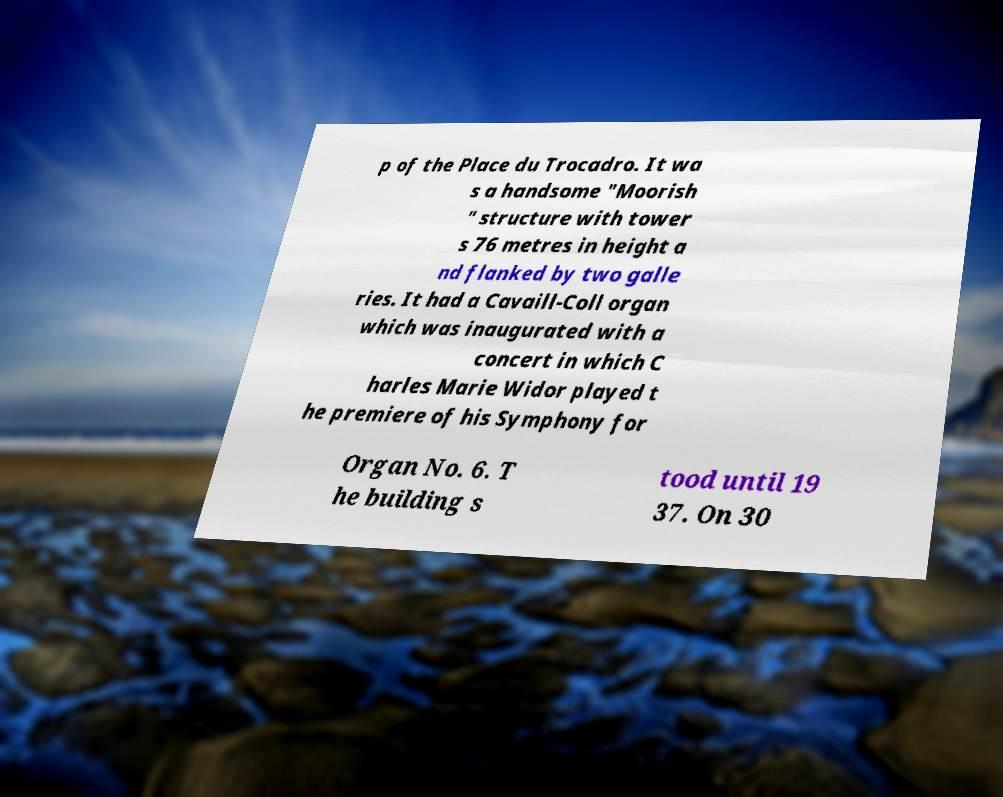Could you assist in decoding the text presented in this image and type it out clearly? p of the Place du Trocadro. It wa s a handsome "Moorish " structure with tower s 76 metres in height a nd flanked by two galle ries. It had a Cavaill-Coll organ which was inaugurated with a concert in which C harles Marie Widor played t he premiere of his Symphony for Organ No. 6. T he building s tood until 19 37. On 30 